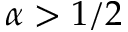Convert formula to latex. <formula><loc_0><loc_0><loc_500><loc_500>\alpha > 1 / 2</formula> 